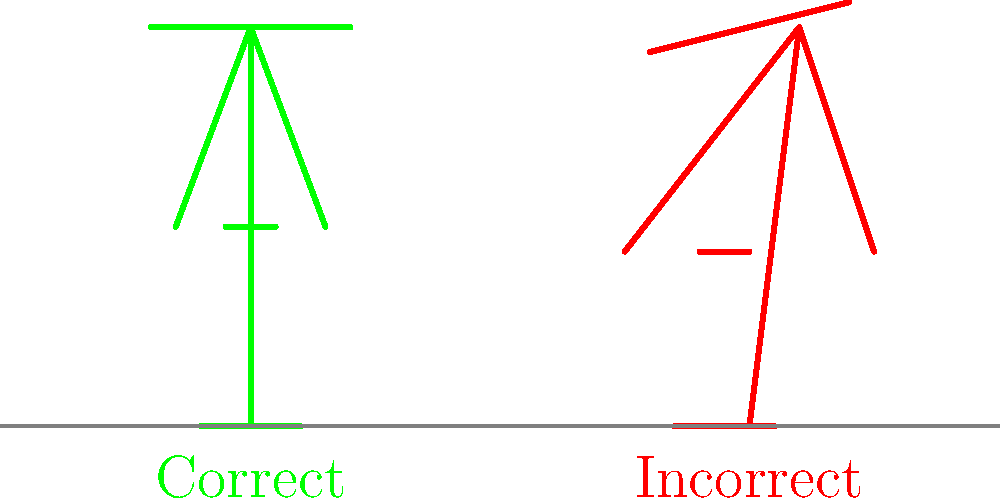As a nurse working long shifts, which biomechanical principle is most important to maintain proper posture and reduce the risk of musculoskeletal disorders? Refer to the diagram and explain the key differences between the correct and incorrect stances. To answer this question, let's analyze the biomechanical principles illustrated in the diagram:

1. Spinal alignment: 
   - Correct posture: The spine is straight and vertical.
   - Incorrect posture: The spine is curved, leading to increased stress on the back muscles.

2. Shoulder position:
   - Correct posture: Shoulders are level and relaxed.
   - Incorrect posture: Shoulders are uneven, indicating muscle imbalance.

3. Weight distribution:
   - Correct posture: Weight is evenly distributed on both feet.
   - Incorrect posture: Weight is unevenly distributed, potentially causing strain on one side.

4. Hip alignment:
   - Correct posture: Hips are level and aligned with the shoulders.
   - Incorrect posture: Hips are slightly tilted, affecting overall body balance.

5. Arm position:
   - Correct posture: Arms are close to the body, reducing strain on shoulder muscles.
   - Incorrect posture: Arms are further from the body, increasing muscle tension.

The most important biomechanical principle for maintaining proper posture during long shifts is maintaining a neutral spine. This principle encompasses the overall alignment of the body and influences all other aspects of posture.

A neutral spine position:
1. Minimizes the load on the intervertebral discs and spinal ligaments.
2. Reduces muscle tension and fatigue in the back and neck.
3. Promotes better balance and weight distribution.
4. Allows for more efficient movement and reduces the risk of injury.

By maintaining a neutral spine, nurses can reduce the risk of developing musculoskeletal disorders such as lower back pain, which is common in healthcare professionals who spend long hours on their feet.
Answer: Maintaining a neutral spine 